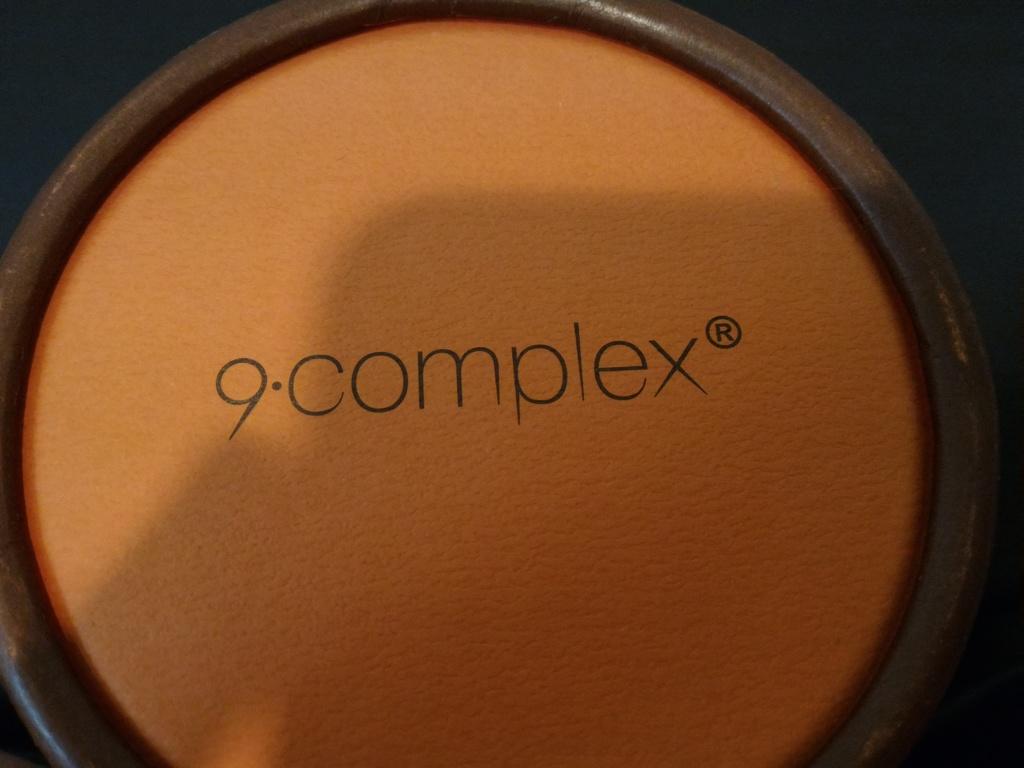What number is shown?
Your response must be concise. 9. Is this a complex brand item?
Your answer should be compact. Yes. 